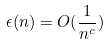<formula> <loc_0><loc_0><loc_500><loc_500>\epsilon ( n ) = O ( \frac { 1 } { n ^ { c } } )</formula> 